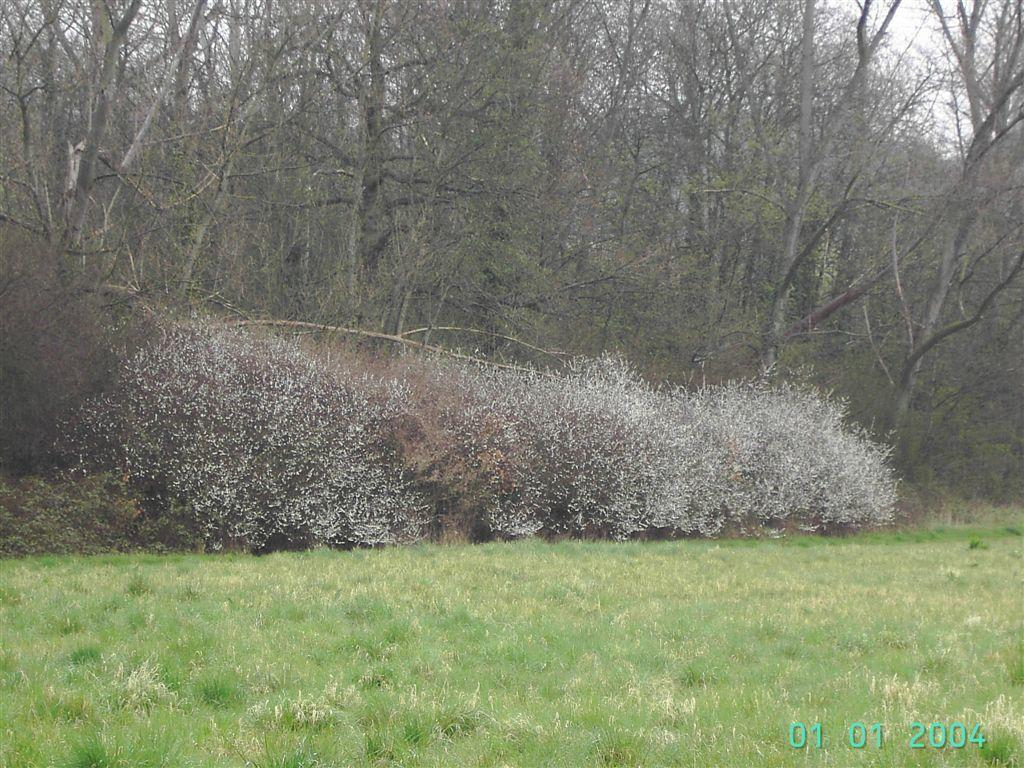What type of surface is visible in the image? There is green grass on the surface in the image. Where are the numbers located in the image? The numbers are on the right side of the image. What type of vegetation can be seen in the image? There are trees, bushes, and plants in the image. What is visible at the top of the image? The sky is visible at the top of the image. What type of unit can be seen measuring the snow in the image? There is no snow or unit present in the image. What impulse causes the plants to grow in the image? The image does not provide information about the impulse that causes the plants to grow; it only shows the plants and other elements in their current state. 